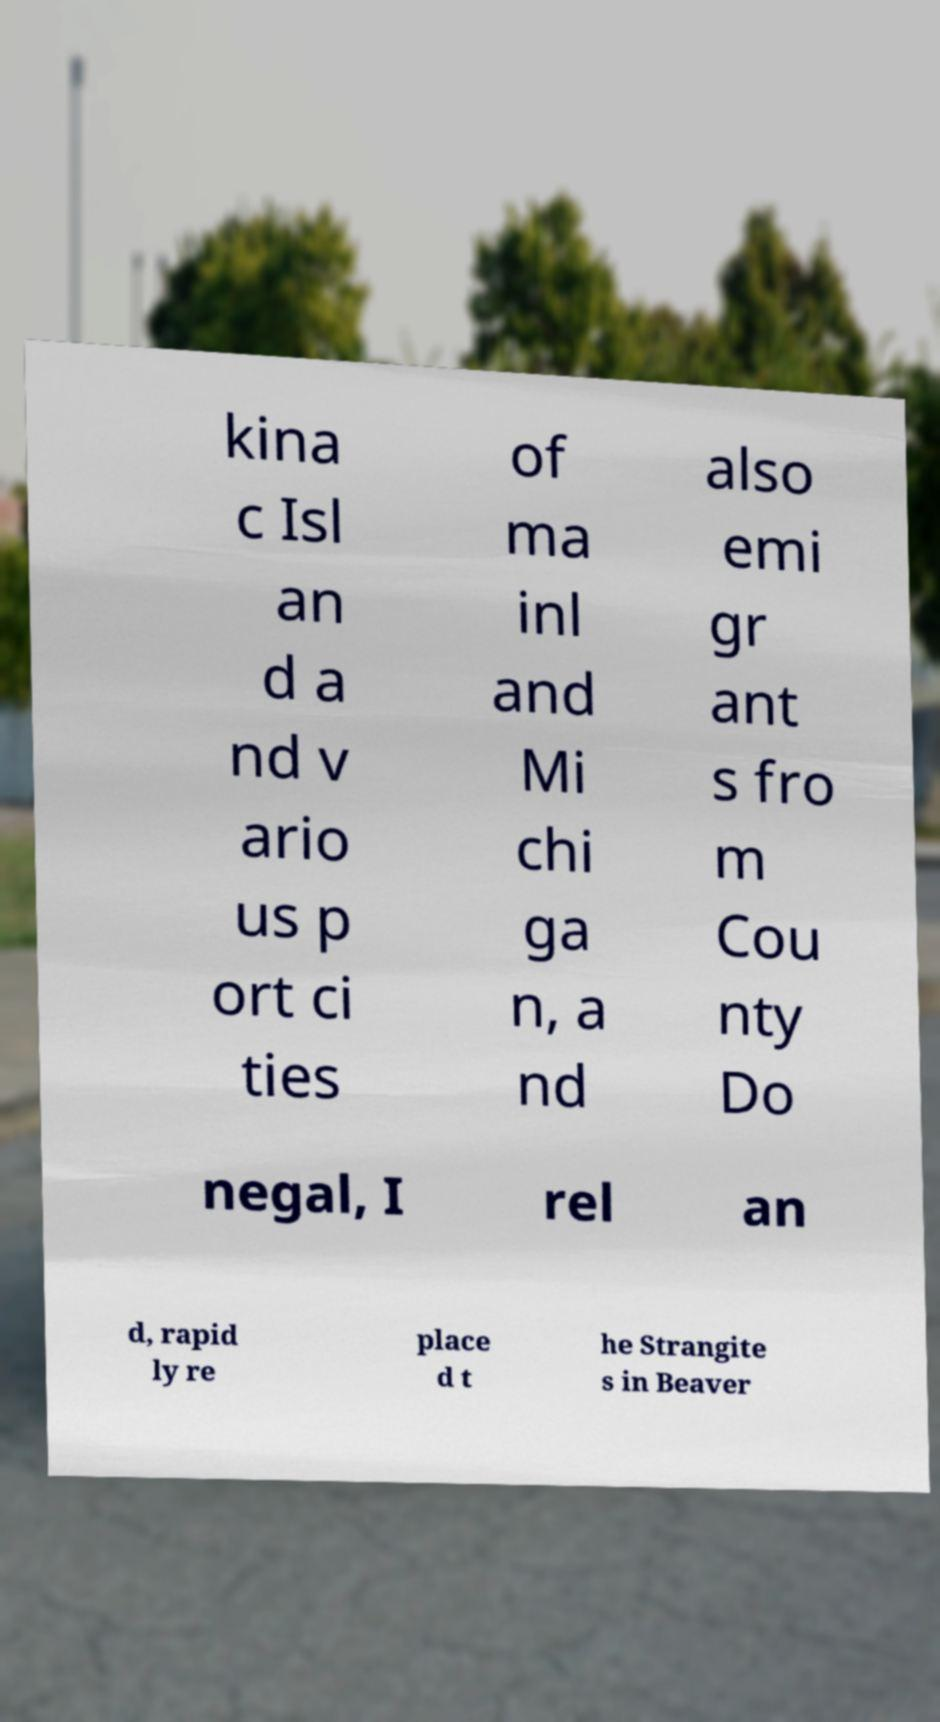Please read and relay the text visible in this image. What does it say? kina c Isl an d a nd v ario us p ort ci ties of ma inl and Mi chi ga n, a nd also emi gr ant s fro m Cou nty Do negal, I rel an d, rapid ly re place d t he Strangite s in Beaver 